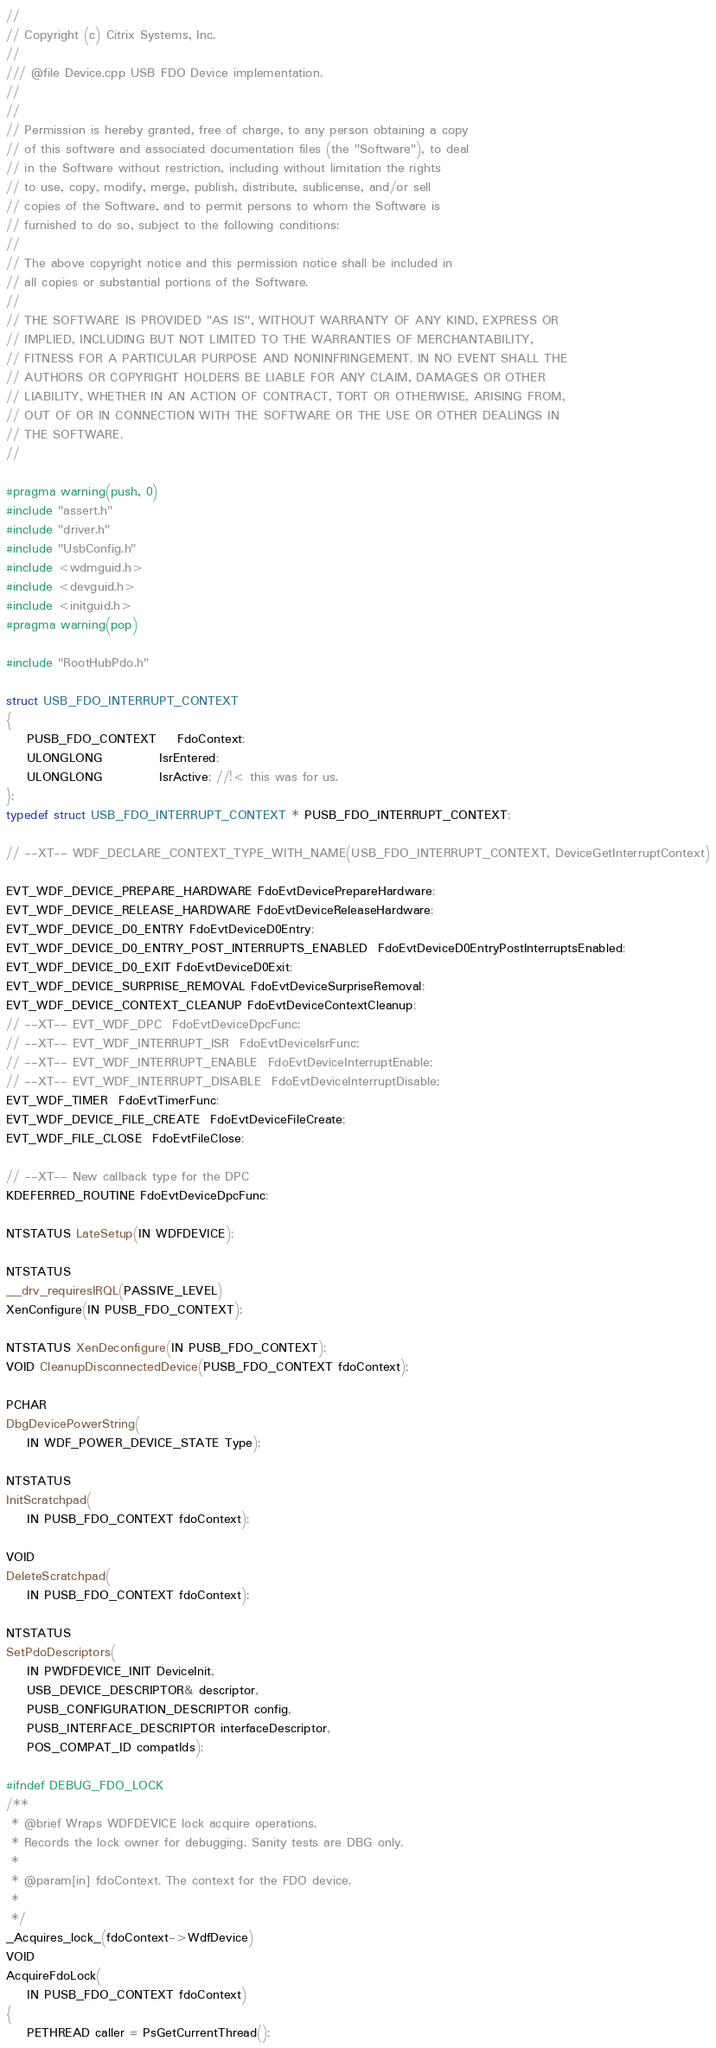<code> <loc_0><loc_0><loc_500><loc_500><_C++_>//
// Copyright (c) Citrix Systems, Inc.
//
/// @file Device.cpp USB FDO Device implementation.
//
//
// Permission is hereby granted, free of charge, to any person obtaining a copy
// of this software and associated documentation files (the "Software"), to deal
// in the Software without restriction, including without limitation the rights
// to use, copy, modify, merge, publish, distribute, sublicense, and/or sell
// copies of the Software, and to permit persons to whom the Software is
// furnished to do so, subject to the following conditions:
//
// The above copyright notice and this permission notice shall be included in
// all copies or substantial portions of the Software.
//
// THE SOFTWARE IS PROVIDED "AS IS", WITHOUT WARRANTY OF ANY KIND, EXPRESS OR
// IMPLIED, INCLUDING BUT NOT LIMITED TO THE WARRANTIES OF MERCHANTABILITY,
// FITNESS FOR A PARTICULAR PURPOSE AND NONINFRINGEMENT. IN NO EVENT SHALL THE
// AUTHORS OR COPYRIGHT HOLDERS BE LIABLE FOR ANY CLAIM, DAMAGES OR OTHER
// LIABILITY, WHETHER IN AN ACTION OF CONTRACT, TORT OR OTHERWISE, ARISING FROM,
// OUT OF OR IN CONNECTION WITH THE SOFTWARE OR THE USE OR OTHER DEALINGS IN
// THE SOFTWARE.
//

#pragma warning(push, 0)
#include "assert.h"
#include "driver.h"
#include "UsbConfig.h"
#include <wdmguid.h>
#include <devguid.h>
#include <initguid.h>
#pragma warning(pop)

#include "RootHubPdo.h"

struct USB_FDO_INTERRUPT_CONTEXT
{
    PUSB_FDO_CONTEXT    FdoContext;
    ULONGLONG           IsrEntered;
    ULONGLONG           IsrActive; //!< this was for us.
};
typedef struct USB_FDO_INTERRUPT_CONTEXT * PUSB_FDO_INTERRUPT_CONTEXT;

// --XT-- WDF_DECLARE_CONTEXT_TYPE_WITH_NAME(USB_FDO_INTERRUPT_CONTEXT, DeviceGetInterruptContext)

EVT_WDF_DEVICE_PREPARE_HARDWARE FdoEvtDevicePrepareHardware;
EVT_WDF_DEVICE_RELEASE_HARDWARE FdoEvtDeviceReleaseHardware;
EVT_WDF_DEVICE_D0_ENTRY FdoEvtDeviceD0Entry;
EVT_WDF_DEVICE_D0_ENTRY_POST_INTERRUPTS_ENABLED  FdoEvtDeviceD0EntryPostInterruptsEnabled;
EVT_WDF_DEVICE_D0_EXIT FdoEvtDeviceD0Exit;
EVT_WDF_DEVICE_SURPRISE_REMOVAL FdoEvtDeviceSurpriseRemoval;
EVT_WDF_DEVICE_CONTEXT_CLEANUP FdoEvtDeviceContextCleanup;
// --XT-- EVT_WDF_DPC  FdoEvtDeviceDpcFunc;
// --XT-- EVT_WDF_INTERRUPT_ISR  FdoEvtDeviceIsrFunc;
// --XT-- EVT_WDF_INTERRUPT_ENABLE  FdoEvtDeviceInterruptEnable;
// --XT-- EVT_WDF_INTERRUPT_DISABLE  FdoEvtDeviceInterruptDisable;
EVT_WDF_TIMER  FdoEvtTimerFunc;
EVT_WDF_DEVICE_FILE_CREATE  FdoEvtDeviceFileCreate;
EVT_WDF_FILE_CLOSE  FdoEvtFileClose;

// --XT-- New callback type for the DPC
KDEFERRED_ROUTINE FdoEvtDeviceDpcFunc;

NTSTATUS LateSetup(IN WDFDEVICE);

NTSTATUS
__drv_requiresIRQL(PASSIVE_LEVEL)
XenConfigure(IN PUSB_FDO_CONTEXT);

NTSTATUS XenDeconfigure(IN PUSB_FDO_CONTEXT);
VOID CleanupDisconnectedDevice(PUSB_FDO_CONTEXT fdoContext);

PCHAR
DbgDevicePowerString(
    IN WDF_POWER_DEVICE_STATE Type);

NTSTATUS
InitScratchpad(
    IN PUSB_FDO_CONTEXT fdoContext);

VOID
DeleteScratchpad(
    IN PUSB_FDO_CONTEXT fdoContext);

NTSTATUS
SetPdoDescriptors(
    IN PWDFDEVICE_INIT DeviceInit,
    USB_DEVICE_DESCRIPTOR& descriptor,
    PUSB_CONFIGURATION_DESCRIPTOR config,
    PUSB_INTERFACE_DESCRIPTOR interfaceDescriptor,
    POS_COMPAT_ID compatIds);

#ifndef DEBUG_FDO_LOCK
/**
 * @brief Wraps WDFDEVICE lock acquire operations.
 * Records the lock owner for debugging. Sanity tests are DBG only.
 *
 * @param[in] fdoContext. The context for the FDO device.
 *
 */
_Acquires_lock_(fdoContext->WdfDevice)
VOID
AcquireFdoLock(
    IN PUSB_FDO_CONTEXT fdoContext)
{
    PETHREAD caller = PsGetCurrentThread();</code> 